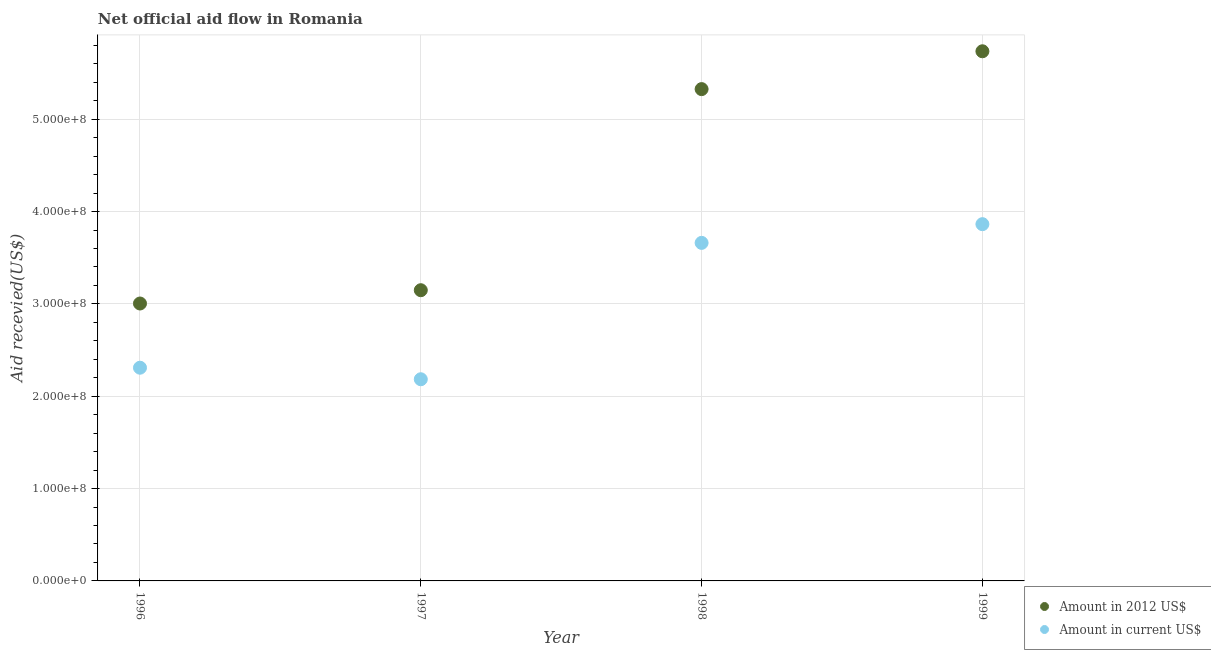Is the number of dotlines equal to the number of legend labels?
Your answer should be very brief. Yes. What is the amount of aid received(expressed in 2012 us$) in 1999?
Ensure brevity in your answer.  5.74e+08. Across all years, what is the maximum amount of aid received(expressed in us$)?
Make the answer very short. 3.86e+08. Across all years, what is the minimum amount of aid received(expressed in us$)?
Provide a succinct answer. 2.18e+08. In which year was the amount of aid received(expressed in 2012 us$) maximum?
Give a very brief answer. 1999. What is the total amount of aid received(expressed in 2012 us$) in the graph?
Provide a succinct answer. 1.72e+09. What is the difference between the amount of aid received(expressed in us$) in 1997 and that in 1998?
Your answer should be compact. -1.48e+08. What is the difference between the amount of aid received(expressed in us$) in 1997 and the amount of aid received(expressed in 2012 us$) in 1998?
Give a very brief answer. -3.14e+08. What is the average amount of aid received(expressed in 2012 us$) per year?
Your response must be concise. 4.30e+08. In the year 1997, what is the difference between the amount of aid received(expressed in 2012 us$) and amount of aid received(expressed in us$)?
Make the answer very short. 9.64e+07. What is the ratio of the amount of aid received(expressed in 2012 us$) in 1998 to that in 1999?
Keep it short and to the point. 0.93. Is the difference between the amount of aid received(expressed in us$) in 1996 and 1998 greater than the difference between the amount of aid received(expressed in 2012 us$) in 1996 and 1998?
Your answer should be very brief. Yes. What is the difference between the highest and the second highest amount of aid received(expressed in 2012 us$)?
Provide a succinct answer. 4.10e+07. What is the difference between the highest and the lowest amount of aid received(expressed in us$)?
Ensure brevity in your answer.  1.68e+08. In how many years, is the amount of aid received(expressed in us$) greater than the average amount of aid received(expressed in us$) taken over all years?
Keep it short and to the point. 2. Does the amount of aid received(expressed in 2012 us$) monotonically increase over the years?
Give a very brief answer. Yes. How many years are there in the graph?
Your answer should be compact. 4. Are the values on the major ticks of Y-axis written in scientific E-notation?
Your answer should be very brief. Yes. Does the graph contain grids?
Provide a short and direct response. Yes. What is the title of the graph?
Ensure brevity in your answer.  Net official aid flow in Romania. What is the label or title of the Y-axis?
Give a very brief answer. Aid recevied(US$). What is the Aid recevied(US$) of Amount in 2012 US$ in 1996?
Keep it short and to the point. 3.00e+08. What is the Aid recevied(US$) in Amount in current US$ in 1996?
Offer a very short reply. 2.31e+08. What is the Aid recevied(US$) in Amount in 2012 US$ in 1997?
Give a very brief answer. 3.15e+08. What is the Aid recevied(US$) of Amount in current US$ in 1997?
Your answer should be very brief. 2.18e+08. What is the Aid recevied(US$) in Amount in 2012 US$ in 1998?
Give a very brief answer. 5.33e+08. What is the Aid recevied(US$) of Amount in current US$ in 1998?
Your answer should be very brief. 3.66e+08. What is the Aid recevied(US$) of Amount in 2012 US$ in 1999?
Provide a succinct answer. 5.74e+08. What is the Aid recevied(US$) in Amount in current US$ in 1999?
Give a very brief answer. 3.86e+08. Across all years, what is the maximum Aid recevied(US$) in Amount in 2012 US$?
Your answer should be very brief. 5.74e+08. Across all years, what is the maximum Aid recevied(US$) of Amount in current US$?
Provide a succinct answer. 3.86e+08. Across all years, what is the minimum Aid recevied(US$) in Amount in 2012 US$?
Your answer should be compact. 3.00e+08. Across all years, what is the minimum Aid recevied(US$) in Amount in current US$?
Your answer should be very brief. 2.18e+08. What is the total Aid recevied(US$) of Amount in 2012 US$ in the graph?
Ensure brevity in your answer.  1.72e+09. What is the total Aid recevied(US$) of Amount in current US$ in the graph?
Make the answer very short. 1.20e+09. What is the difference between the Aid recevied(US$) in Amount in 2012 US$ in 1996 and that in 1997?
Your response must be concise. -1.44e+07. What is the difference between the Aid recevied(US$) in Amount in current US$ in 1996 and that in 1997?
Offer a very short reply. 1.25e+07. What is the difference between the Aid recevied(US$) in Amount in 2012 US$ in 1996 and that in 1998?
Make the answer very short. -2.32e+08. What is the difference between the Aid recevied(US$) of Amount in current US$ in 1996 and that in 1998?
Provide a short and direct response. -1.35e+08. What is the difference between the Aid recevied(US$) in Amount in 2012 US$ in 1996 and that in 1999?
Give a very brief answer. -2.73e+08. What is the difference between the Aid recevied(US$) in Amount in current US$ in 1996 and that in 1999?
Your response must be concise. -1.55e+08. What is the difference between the Aid recevied(US$) in Amount in 2012 US$ in 1997 and that in 1998?
Keep it short and to the point. -2.18e+08. What is the difference between the Aid recevied(US$) in Amount in current US$ in 1997 and that in 1998?
Offer a very short reply. -1.48e+08. What is the difference between the Aid recevied(US$) in Amount in 2012 US$ in 1997 and that in 1999?
Provide a short and direct response. -2.59e+08. What is the difference between the Aid recevied(US$) in Amount in current US$ in 1997 and that in 1999?
Your answer should be compact. -1.68e+08. What is the difference between the Aid recevied(US$) of Amount in 2012 US$ in 1998 and that in 1999?
Offer a terse response. -4.10e+07. What is the difference between the Aid recevied(US$) in Amount in current US$ in 1998 and that in 1999?
Give a very brief answer. -2.03e+07. What is the difference between the Aid recevied(US$) in Amount in 2012 US$ in 1996 and the Aid recevied(US$) in Amount in current US$ in 1997?
Offer a very short reply. 8.20e+07. What is the difference between the Aid recevied(US$) of Amount in 2012 US$ in 1996 and the Aid recevied(US$) of Amount in current US$ in 1998?
Ensure brevity in your answer.  -6.57e+07. What is the difference between the Aid recevied(US$) in Amount in 2012 US$ in 1996 and the Aid recevied(US$) in Amount in current US$ in 1999?
Your response must be concise. -8.59e+07. What is the difference between the Aid recevied(US$) of Amount in 2012 US$ in 1997 and the Aid recevied(US$) of Amount in current US$ in 1998?
Ensure brevity in your answer.  -5.13e+07. What is the difference between the Aid recevied(US$) in Amount in 2012 US$ in 1997 and the Aid recevied(US$) in Amount in current US$ in 1999?
Your answer should be compact. -7.15e+07. What is the difference between the Aid recevied(US$) of Amount in 2012 US$ in 1998 and the Aid recevied(US$) of Amount in current US$ in 1999?
Give a very brief answer. 1.46e+08. What is the average Aid recevied(US$) in Amount in 2012 US$ per year?
Provide a succinct answer. 4.30e+08. What is the average Aid recevied(US$) in Amount in current US$ per year?
Give a very brief answer. 3.00e+08. In the year 1996, what is the difference between the Aid recevied(US$) in Amount in 2012 US$ and Aid recevied(US$) in Amount in current US$?
Ensure brevity in your answer.  6.95e+07. In the year 1997, what is the difference between the Aid recevied(US$) of Amount in 2012 US$ and Aid recevied(US$) of Amount in current US$?
Your response must be concise. 9.64e+07. In the year 1998, what is the difference between the Aid recevied(US$) of Amount in 2012 US$ and Aid recevied(US$) of Amount in current US$?
Provide a succinct answer. 1.67e+08. In the year 1999, what is the difference between the Aid recevied(US$) of Amount in 2012 US$ and Aid recevied(US$) of Amount in current US$?
Provide a short and direct response. 1.87e+08. What is the ratio of the Aid recevied(US$) of Amount in 2012 US$ in 1996 to that in 1997?
Your response must be concise. 0.95. What is the ratio of the Aid recevied(US$) of Amount in current US$ in 1996 to that in 1997?
Ensure brevity in your answer.  1.06. What is the ratio of the Aid recevied(US$) of Amount in 2012 US$ in 1996 to that in 1998?
Ensure brevity in your answer.  0.56. What is the ratio of the Aid recevied(US$) of Amount in current US$ in 1996 to that in 1998?
Offer a very short reply. 0.63. What is the ratio of the Aid recevied(US$) in Amount in 2012 US$ in 1996 to that in 1999?
Provide a succinct answer. 0.52. What is the ratio of the Aid recevied(US$) of Amount in current US$ in 1996 to that in 1999?
Provide a succinct answer. 0.6. What is the ratio of the Aid recevied(US$) of Amount in 2012 US$ in 1997 to that in 1998?
Provide a short and direct response. 0.59. What is the ratio of the Aid recevied(US$) of Amount in current US$ in 1997 to that in 1998?
Make the answer very short. 0.6. What is the ratio of the Aid recevied(US$) of Amount in 2012 US$ in 1997 to that in 1999?
Provide a succinct answer. 0.55. What is the ratio of the Aid recevied(US$) in Amount in current US$ in 1997 to that in 1999?
Keep it short and to the point. 0.57. What is the ratio of the Aid recevied(US$) of Amount in 2012 US$ in 1998 to that in 1999?
Make the answer very short. 0.93. What is the ratio of the Aid recevied(US$) of Amount in current US$ in 1998 to that in 1999?
Ensure brevity in your answer.  0.95. What is the difference between the highest and the second highest Aid recevied(US$) of Amount in 2012 US$?
Ensure brevity in your answer.  4.10e+07. What is the difference between the highest and the second highest Aid recevied(US$) of Amount in current US$?
Offer a terse response. 2.03e+07. What is the difference between the highest and the lowest Aid recevied(US$) in Amount in 2012 US$?
Offer a terse response. 2.73e+08. What is the difference between the highest and the lowest Aid recevied(US$) of Amount in current US$?
Offer a very short reply. 1.68e+08. 